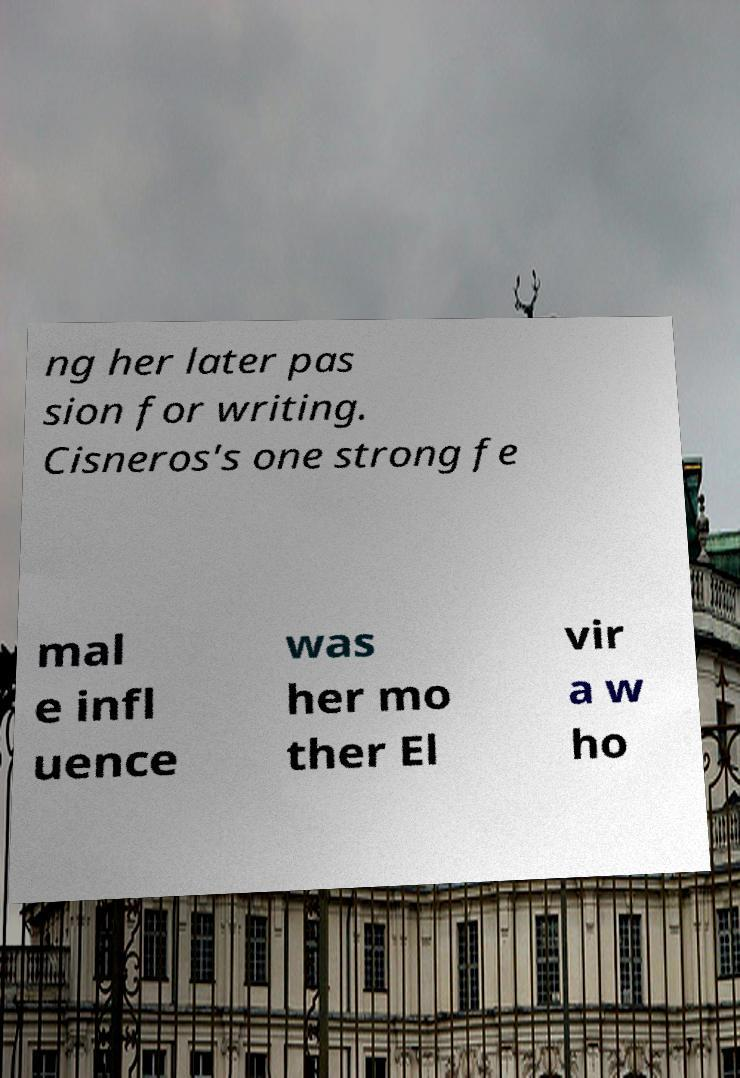Please identify and transcribe the text found in this image. ng her later pas sion for writing. Cisneros's one strong fe mal e infl uence was her mo ther El vir a w ho 